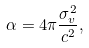<formula> <loc_0><loc_0><loc_500><loc_500>\alpha = 4 \pi \frac { \sigma _ { v } ^ { 2 } } { c ^ { 2 } } ,</formula> 